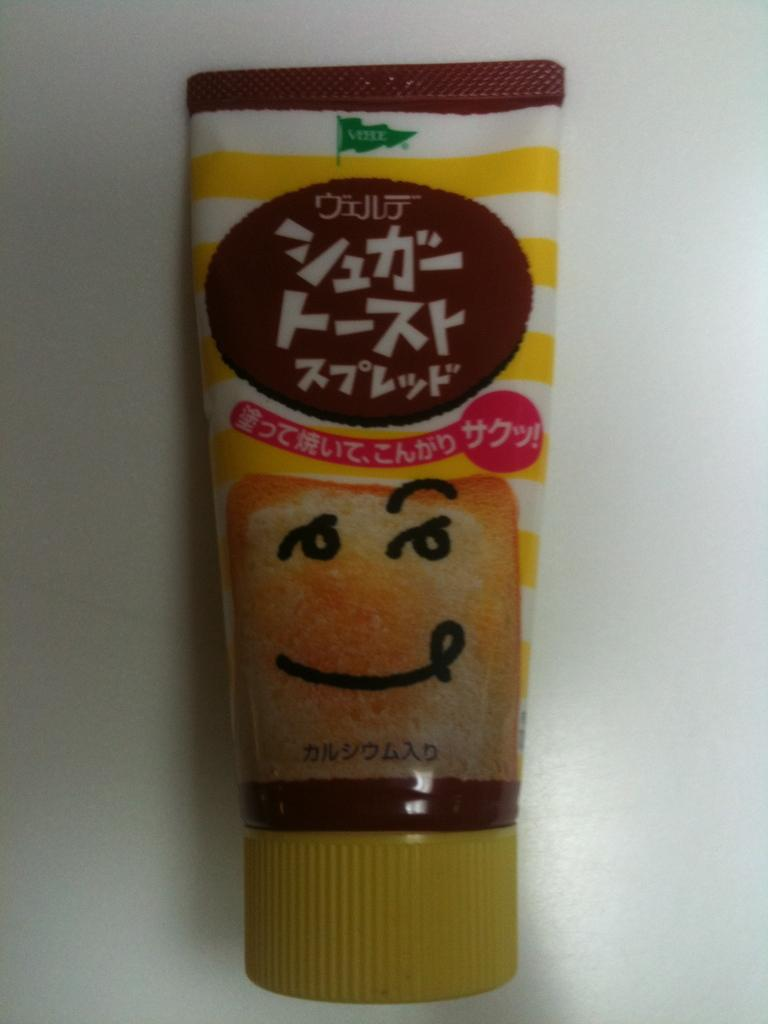What is the main object in the image? There is a tube in the image. What can be found on the tube? There is text present on the tube. What color is the background of the image? The background of the image is white. What type of question is being asked in the image? There is no question present in the image; it features a tube with text on it. Can you hear any noise coming from the tube in the image? There is no noise coming from the tube in the image, as it is a static object. 